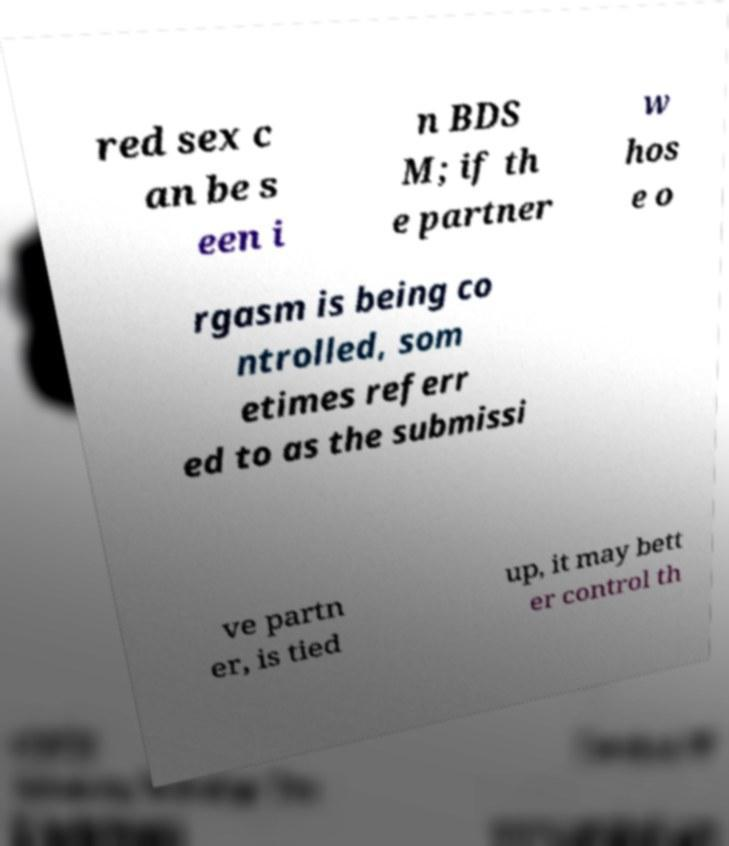Please identify and transcribe the text found in this image. red sex c an be s een i n BDS M; if th e partner w hos e o rgasm is being co ntrolled, som etimes referr ed to as the submissi ve partn er, is tied up, it may bett er control th 